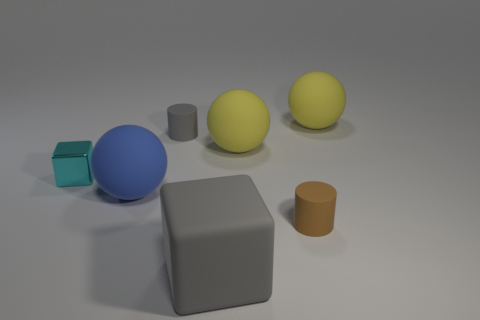How many objects are there in the image, and can you classify them by shape? There are six objects in the image. They can be classified by shape as follows: two spheres, one cube, one cylinder, one cuboid, and a small object which appears cylindrical but its exact shape is obstructed.  Are there any patterns or symmetry in the arrangement of the objects? The objects are arranged without any clear pattern or symmetry. They are placed at varying distances from each other, and there's no evident sequence or alignment that suggests intentional patterning or symmetry. 